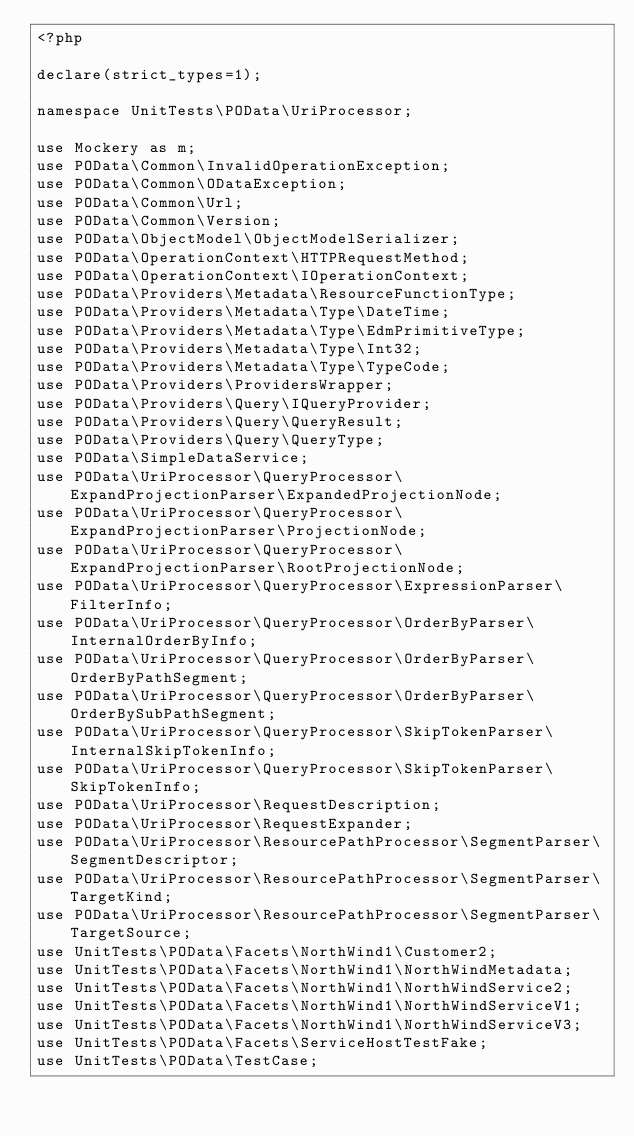<code> <loc_0><loc_0><loc_500><loc_500><_PHP_><?php

declare(strict_types=1);

namespace UnitTests\POData\UriProcessor;

use Mockery as m;
use POData\Common\InvalidOperationException;
use POData\Common\ODataException;
use POData\Common\Url;
use POData\Common\Version;
use POData\ObjectModel\ObjectModelSerializer;
use POData\OperationContext\HTTPRequestMethod;
use POData\OperationContext\IOperationContext;
use POData\Providers\Metadata\ResourceFunctionType;
use POData\Providers\Metadata\Type\DateTime;
use POData\Providers\Metadata\Type\EdmPrimitiveType;
use POData\Providers\Metadata\Type\Int32;
use POData\Providers\Metadata\Type\TypeCode;
use POData\Providers\ProvidersWrapper;
use POData\Providers\Query\IQueryProvider;
use POData\Providers\Query\QueryResult;
use POData\Providers\Query\QueryType;
use POData\SimpleDataService;
use POData\UriProcessor\QueryProcessor\ExpandProjectionParser\ExpandedProjectionNode;
use POData\UriProcessor\QueryProcessor\ExpandProjectionParser\ProjectionNode;
use POData\UriProcessor\QueryProcessor\ExpandProjectionParser\RootProjectionNode;
use POData\UriProcessor\QueryProcessor\ExpressionParser\FilterInfo;
use POData\UriProcessor\QueryProcessor\OrderByParser\InternalOrderByInfo;
use POData\UriProcessor\QueryProcessor\OrderByParser\OrderByPathSegment;
use POData\UriProcessor\QueryProcessor\OrderByParser\OrderBySubPathSegment;
use POData\UriProcessor\QueryProcessor\SkipTokenParser\InternalSkipTokenInfo;
use POData\UriProcessor\QueryProcessor\SkipTokenParser\SkipTokenInfo;
use POData\UriProcessor\RequestDescription;
use POData\UriProcessor\RequestExpander;
use POData\UriProcessor\ResourcePathProcessor\SegmentParser\SegmentDescriptor;
use POData\UriProcessor\ResourcePathProcessor\SegmentParser\TargetKind;
use POData\UriProcessor\ResourcePathProcessor\SegmentParser\TargetSource;
use UnitTests\POData\Facets\NorthWind1\Customer2;
use UnitTests\POData\Facets\NorthWind1\NorthWindMetadata;
use UnitTests\POData\Facets\NorthWind1\NorthWindService2;
use UnitTests\POData\Facets\NorthWind1\NorthWindServiceV1;
use UnitTests\POData\Facets\NorthWind1\NorthWindServiceV3;
use UnitTests\POData\Facets\ServiceHostTestFake;
use UnitTests\POData\TestCase;
</code> 